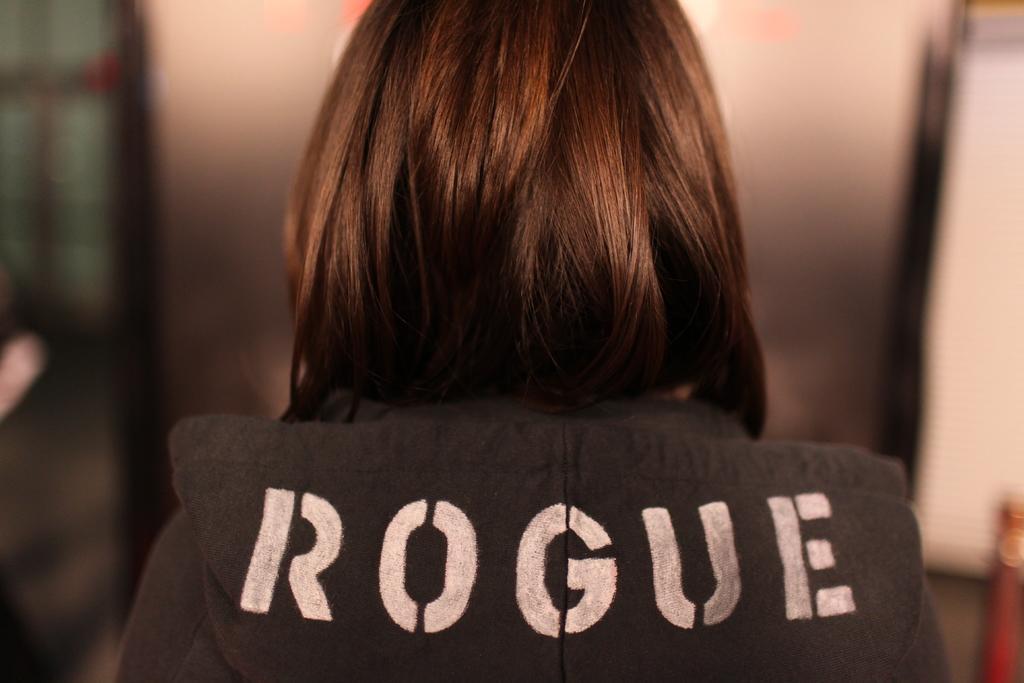In one or two sentences, can you explain what this image depicts? In this image in front there is a person. Beside her there is a pole and the background of the image is blur. 